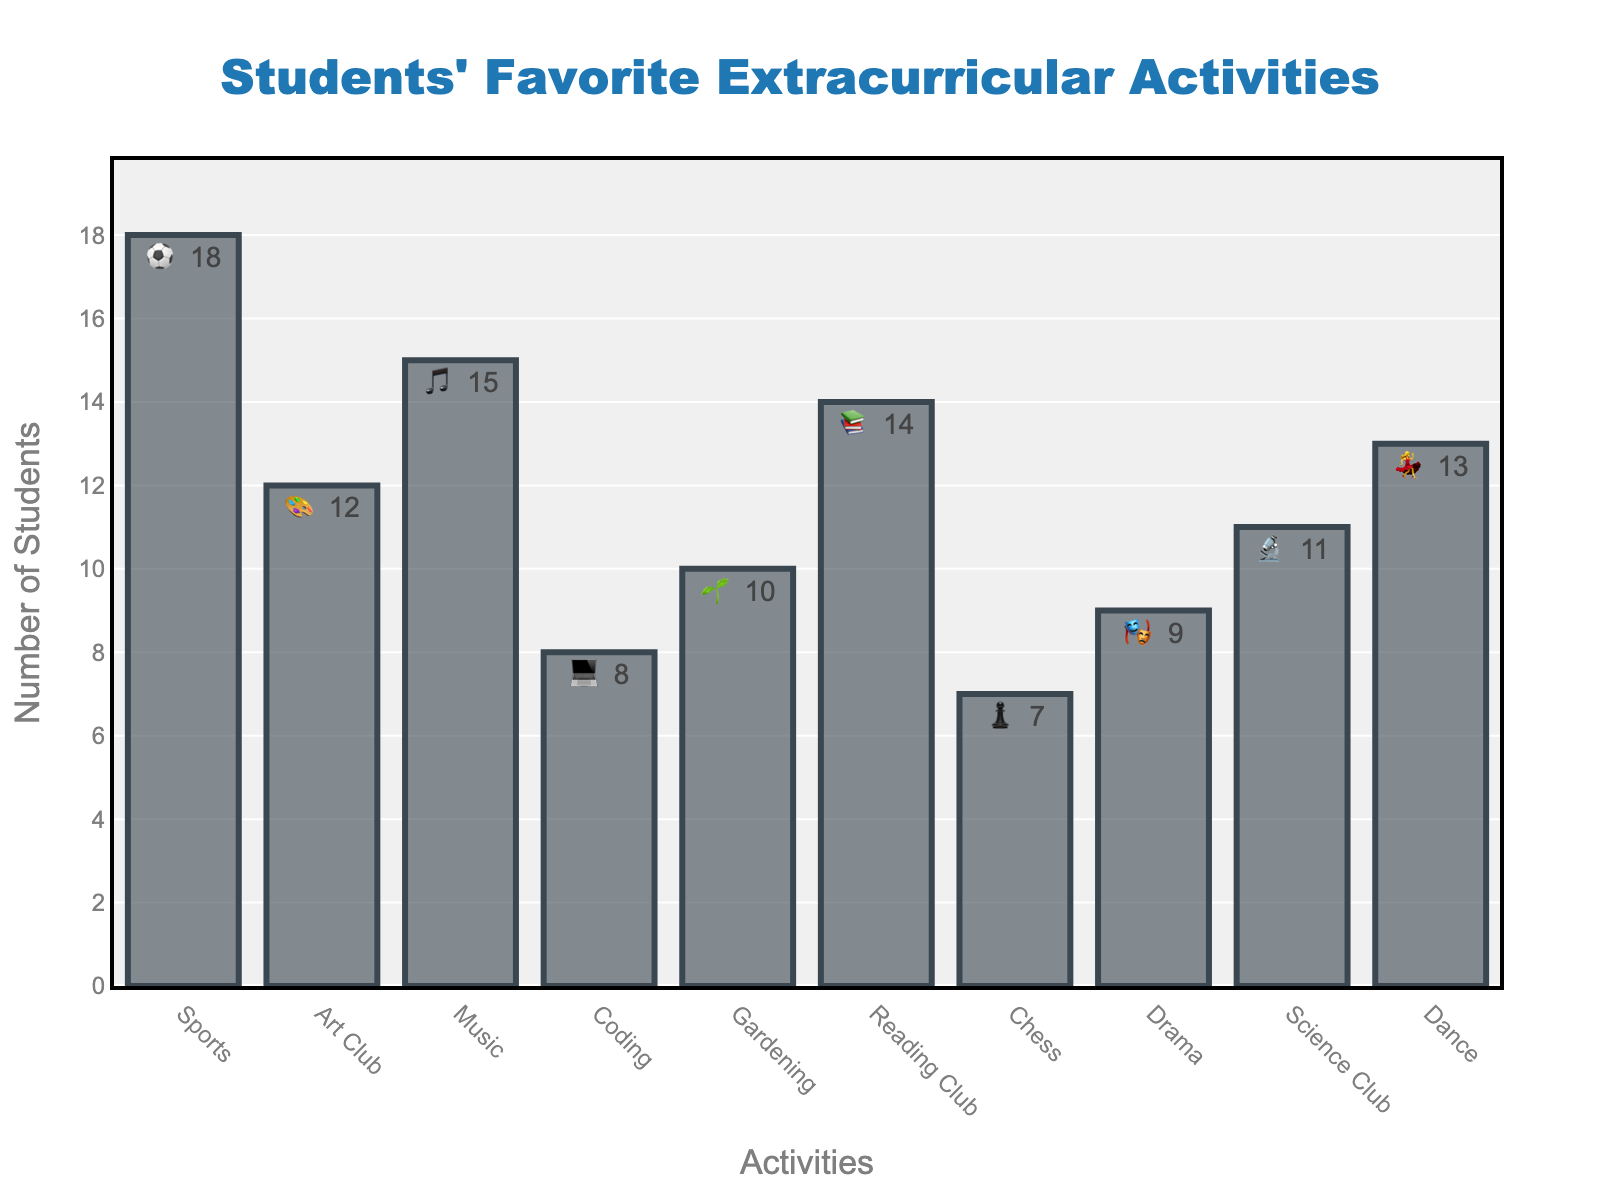What is the title of the chart? The title is located at the top center of the chart.
Answer: Students' Favorite Extracurricular Activities How many extracurricular activities have more than 10 students participating? Look at the 'Count' values for each activity. Count the activities with values greater than 10.
Answer: 6 Which activity has the lowest number of participants? Identify the activity with the smallest 'Count' value.
Answer: Chess ♟️ How many students participate in both Music and Dance activities combined? Add the 'Count' values for Music and Dance.
Answer: 15 (Music) + 13 (Dance) = 28 Which activities have a count higher than Reading Club but lower than Sports? Find the 'Count' value for Reading Club and Sports, then identify which activities fall in between.
Answer: Dance, Music, Art Club What is the average number of students participating in Gardening, Coding, and Drama? Add the 'Count' values for Gardening, Coding, and Drama, then divide by 3.
Answer: (10 + 8 + 9) / 3 = 9 How many more students participate in Sports compared to Chess? Subtract the 'Count' value for Chess from the 'Count' value for Sports.
Answer: 18 (Sports) - 7 (Chess) = 11 Which activities have an emoji representing them? Look at the 'Emoji' column to see which activities have corresponding emojis.
Answer: All activities have an emoji Is the number of students in Reading Club greater than in Science Club? Compare the 'Count' value for Reading Club and Science Club.
Answer: Yes What is the combined percentage of students in Art Club and Science Club if the total number of students is 117? First, find the total 'Count' which is 117. Then add the 'Count' values for Art Club and Science Club and divide by 117, pass this value into the percentage formula (x100) to get the percentage.
Answer: (12+11)/117 x 100 = 19.7% 